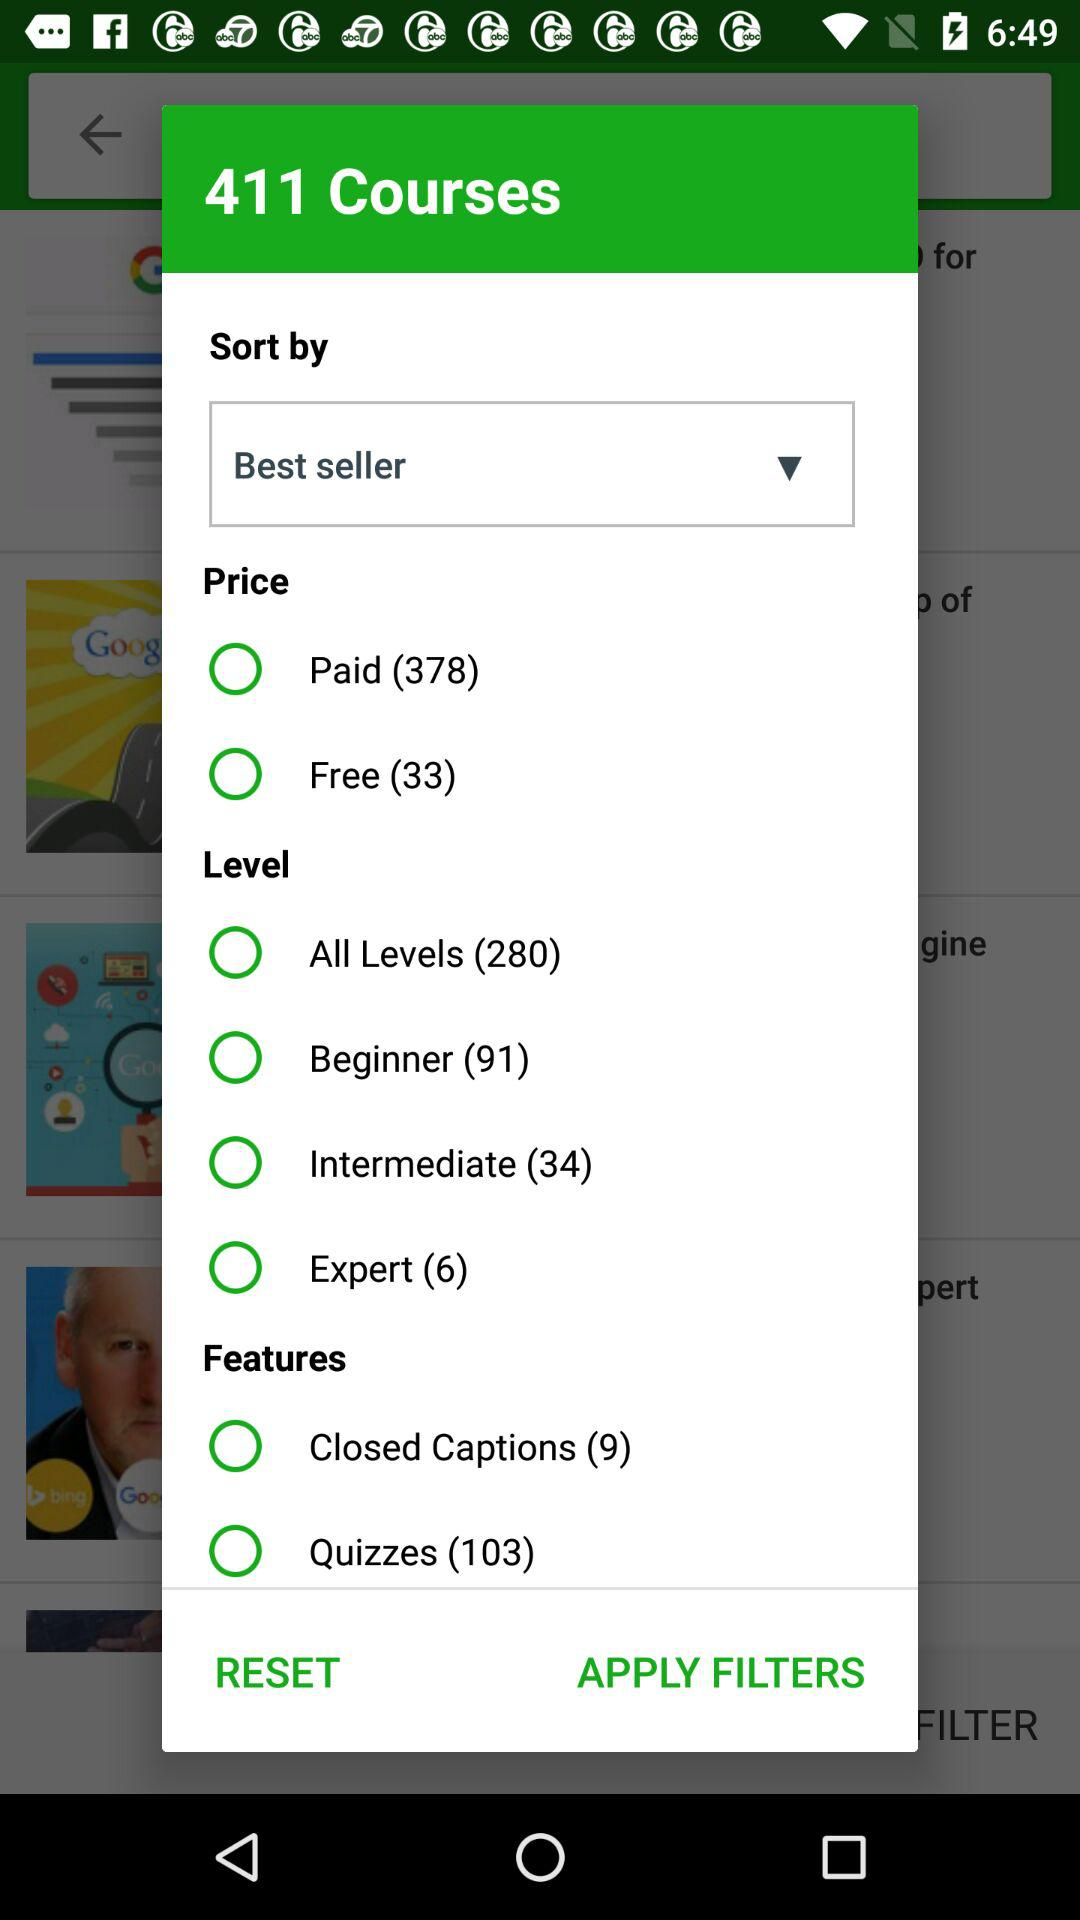How many free and paid courses in total are available? There are 33 free and 378 paid courses available. 